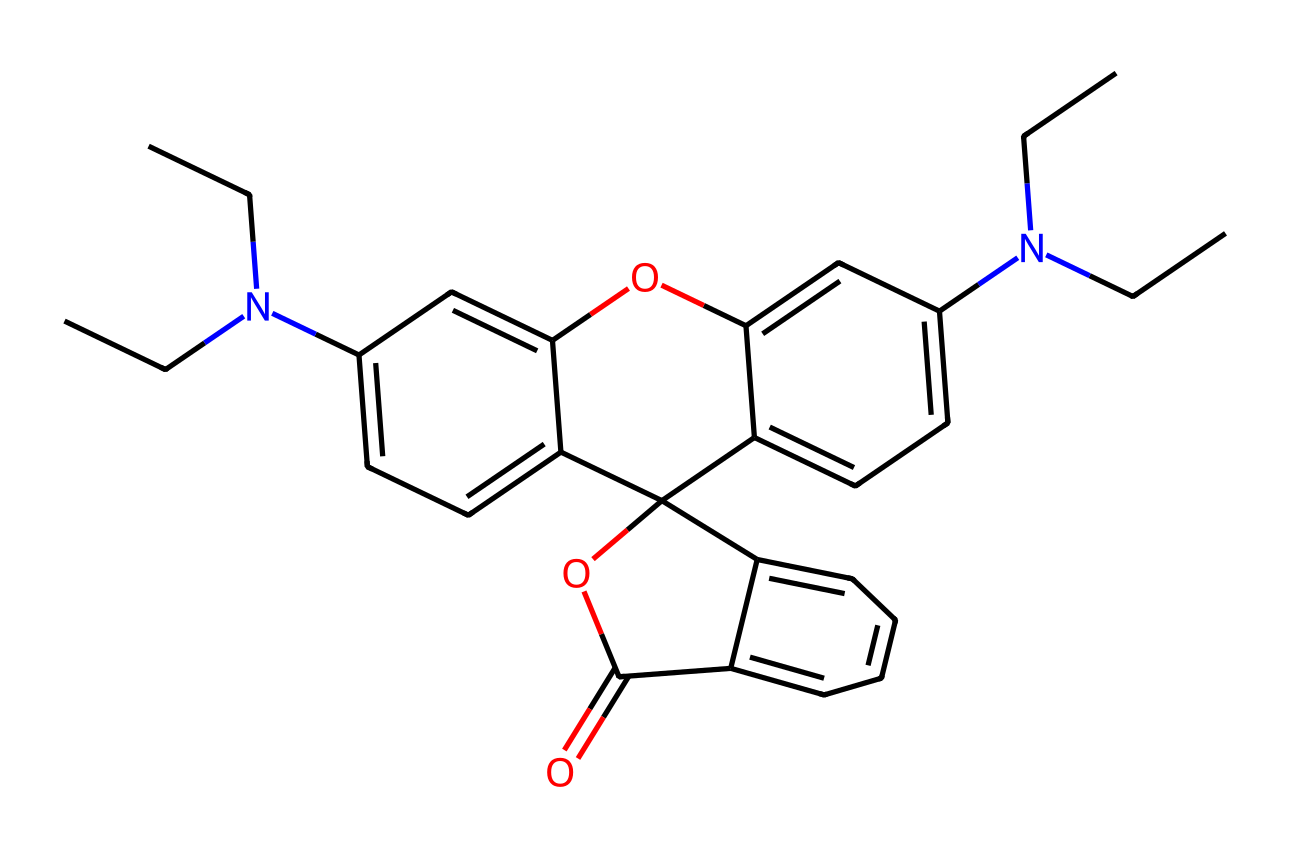What is the molecular formula represented in the chemical structure? To find the molecular formula, count all the atoms of each element present in the structure from the SMILES. The primary elements are carbon (C), hydrogen (H), oxygen (O), and nitrogen (N). After counting, we find there are 25 carbon atoms, 31 hydrogen atoms, 3 oxygen atoms, and 2 nitrogen atoms. Therefore, the molecular formula is C25H31N2O3.
Answer: C25H31N2O3 How many rings are present in the chemical structure? By visually analyzing the structure based on the SMILES, we can identify that there are two fused rings. We can see two distinct cyclic parts that share common atoms, confirming there are two rings in the overall structure.
Answer: 2 What type of functional groups can be identified in this molecule? Looking at the structure, we can identify a few functional groups. The presence of a nitrogen atom indicates an amine group, while the carbonyl part (C=O) suggests a carboxylic acid or ester function. Additionally, the oxygen in the ether-like structure supports the presence of an ether functional group as well.
Answer: amine, ether, ester How do the branched alkyl groups influence the lipophilicity of this detergent? branched alkyl groups such as CCN(CC) contribute to the lipophilicity by increasing the hydrophobic character of the molecule. This is important for solubility in oily stains, making it more effective as a detergent. The more branching, the less compact the structure is, which enhances solubility in non-polar solvents because of greater voluminous character.
Answer: increases lipophilicity What is the main role of the optical brighteners in laundry detergents? Optical brighteners primarily work by absorbing ultraviolet light and re-emitting it as visible blue light, which can make clothes appear brighter and whiter. This process relies on the chemical structure, allowing specific interactions with light. Overall, it compensates for any yellowing that has occurred in fabrics.
Answer: brightening clothes How does the presence of nitrogen atoms affect the detergent's performance? The nitrogen atoms within this structure suggest the presence of amine groups that can enhance the detergent's cleaning performance through interactions with dirt and sweat. These functional groups provide better binding capabilities with negatively charged surfaces of soils and stains, helping in emulsification and removal from fabrics.
Answer: enhances performance 